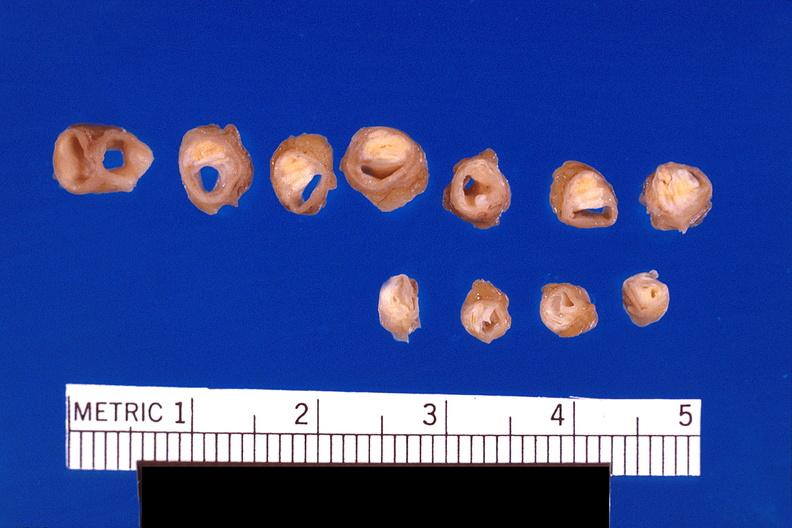does all the fat necrosis show atherosclerosis?
Answer the question using a single word or phrase. No 